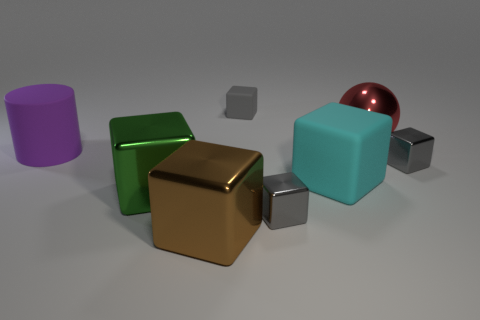How many metallic things are there?
Your response must be concise. 5. How many gray objects are behind the cyan rubber cube and to the left of the red ball?
Offer a terse response. 1. Are there any other things that are the same shape as the red shiny object?
Ensure brevity in your answer.  No. Does the cylinder have the same color as the large shiny thing to the right of the large cyan cube?
Your answer should be very brief. No. The matte object behind the cylinder has what shape?
Your response must be concise. Cube. What number of other objects are the same material as the big sphere?
Offer a terse response. 4. What material is the large cylinder?
Give a very brief answer. Rubber. How many large objects are either rubber things or green metallic cubes?
Make the answer very short. 3. There is a large green metal block; what number of metal things are in front of it?
Make the answer very short. 2. Are there any rubber blocks that have the same color as the large cylinder?
Provide a succinct answer. No. 